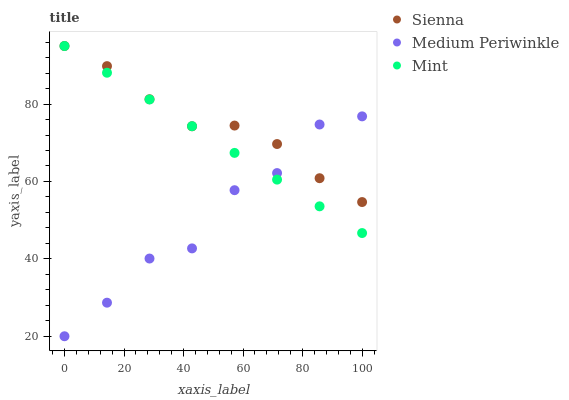Does Medium Periwinkle have the minimum area under the curve?
Answer yes or no. Yes. Does Sienna have the maximum area under the curve?
Answer yes or no. Yes. Does Mint have the minimum area under the curve?
Answer yes or no. No. Does Mint have the maximum area under the curve?
Answer yes or no. No. Is Mint the smoothest?
Answer yes or no. Yes. Is Medium Periwinkle the roughest?
Answer yes or no. Yes. Is Medium Periwinkle the smoothest?
Answer yes or no. No. Is Mint the roughest?
Answer yes or no. No. Does Medium Periwinkle have the lowest value?
Answer yes or no. Yes. Does Mint have the lowest value?
Answer yes or no. No. Does Mint have the highest value?
Answer yes or no. Yes. Does Medium Periwinkle have the highest value?
Answer yes or no. No. Does Sienna intersect Mint?
Answer yes or no. Yes. Is Sienna less than Mint?
Answer yes or no. No. Is Sienna greater than Mint?
Answer yes or no. No. 